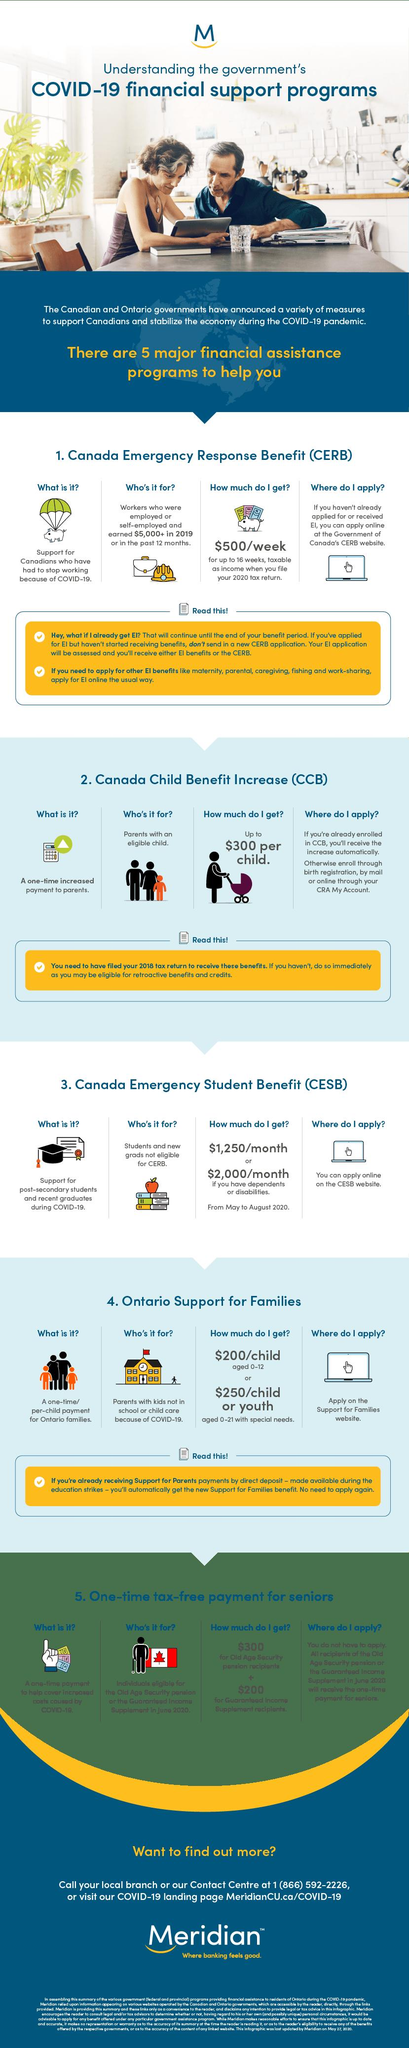Point out several critical features in this image. The Canadian government has introduced the Canada Emergency Response Benefit (CERB) to provide financial assistance to Canadians who have had to stop working due to COVID-19. The Canada Emergency Student Benefit (CESB) is a financial assistance program announced by the Canadian government to support post-secondary students and recent graduates who have been affected by COVID-19. The Canada Child Benefit Increase program offers financial assistance of up to $300 per child to eligible families in Canada. 